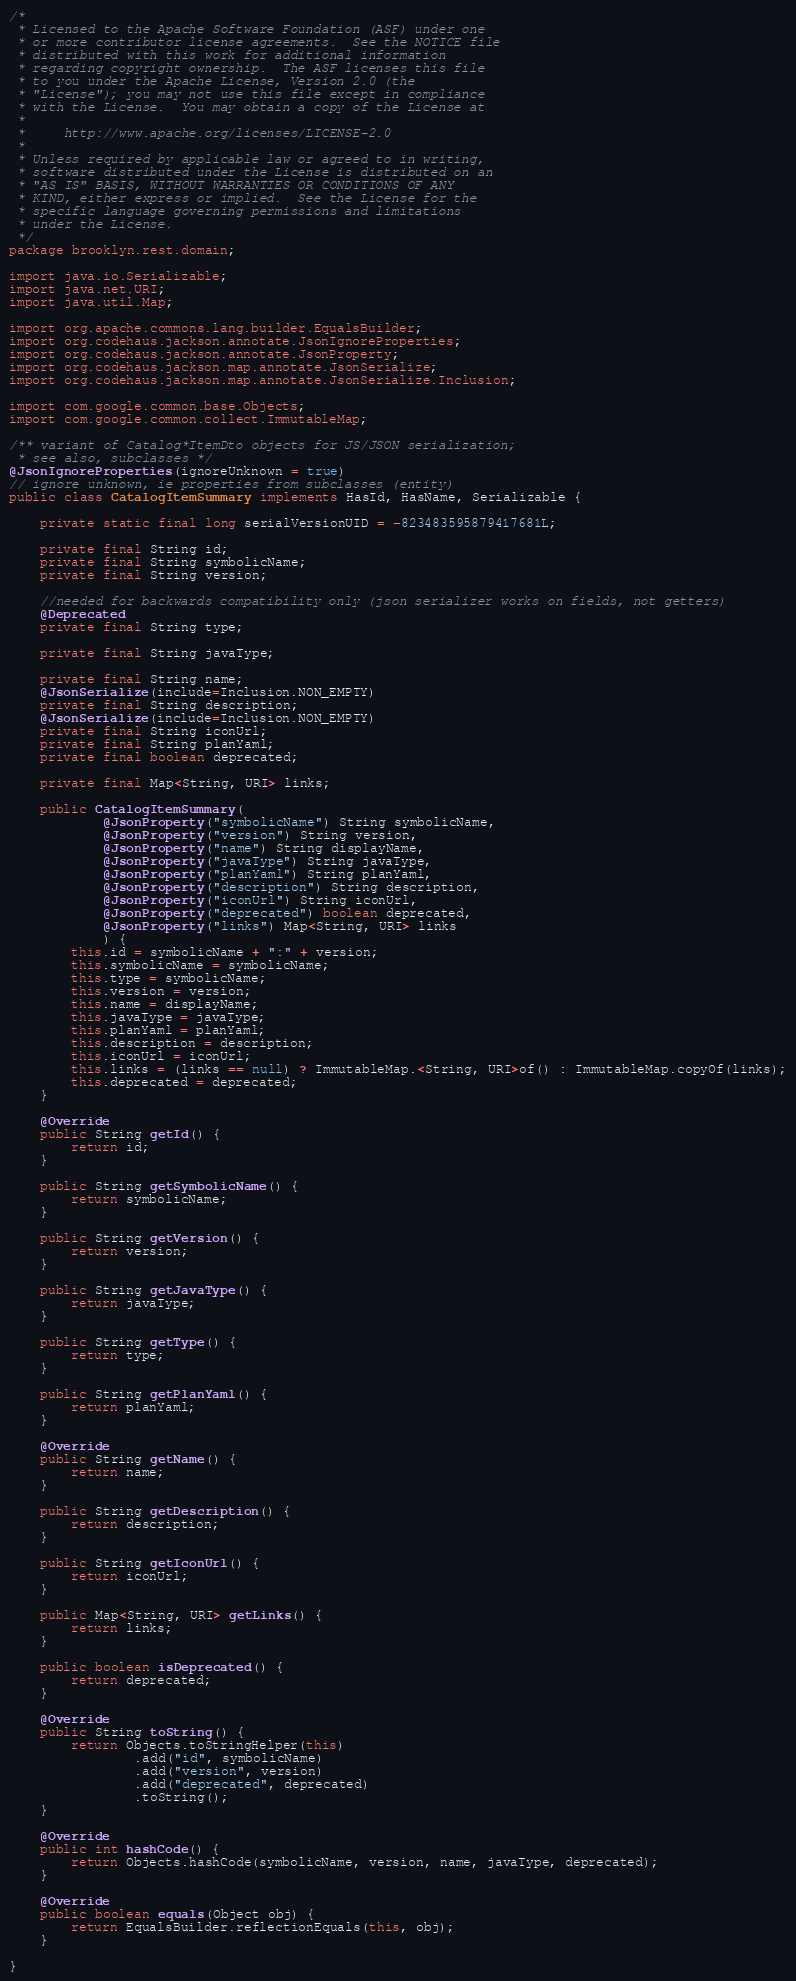<code> <loc_0><loc_0><loc_500><loc_500><_Java_>/*
 * Licensed to the Apache Software Foundation (ASF) under one
 * or more contributor license agreements.  See the NOTICE file
 * distributed with this work for additional information
 * regarding copyright ownership.  The ASF licenses this file
 * to you under the Apache License, Version 2.0 (the
 * "License"); you may not use this file except in compliance
 * with the License.  You may obtain a copy of the License at
 *
 *     http://www.apache.org/licenses/LICENSE-2.0
 *
 * Unless required by applicable law or agreed to in writing,
 * software distributed under the License is distributed on an
 * "AS IS" BASIS, WITHOUT WARRANTIES OR CONDITIONS OF ANY
 * KIND, either express or implied.  See the License for the
 * specific language governing permissions and limitations
 * under the License.
 */
package brooklyn.rest.domain;

import java.io.Serializable;
import java.net.URI;
import java.util.Map;

import org.apache.commons.lang.builder.EqualsBuilder;
import org.codehaus.jackson.annotate.JsonIgnoreProperties;
import org.codehaus.jackson.annotate.JsonProperty;
import org.codehaus.jackson.map.annotate.JsonSerialize;
import org.codehaus.jackson.map.annotate.JsonSerialize.Inclusion;

import com.google.common.base.Objects;
import com.google.common.collect.ImmutableMap;

/** variant of Catalog*ItemDto objects for JS/JSON serialization;
 * see also, subclasses */
@JsonIgnoreProperties(ignoreUnknown = true)
// ignore unknown, ie properties from subclasses (entity)
public class CatalogItemSummary implements HasId, HasName, Serializable {

    private static final long serialVersionUID = -823483595879417681L;
    
    private final String id;
    private final String symbolicName;
    private final String version;

    //needed for backwards compatibility only (json serializer works on fields, not getters)
    @Deprecated
    private final String type;
    
    private final String javaType;
    
    private final String name;
    @JsonSerialize(include=Inclusion.NON_EMPTY)
    private final String description;
    @JsonSerialize(include=Inclusion.NON_EMPTY)
    private final String iconUrl;
    private final String planYaml;
    private final boolean deprecated;
    
    private final Map<String, URI> links;

    public CatalogItemSummary(
            @JsonProperty("symbolicName") String symbolicName,
            @JsonProperty("version") String version,
            @JsonProperty("name") String displayName,
            @JsonProperty("javaType") String javaType,
            @JsonProperty("planYaml") String planYaml,
            @JsonProperty("description") String description,
            @JsonProperty("iconUrl") String iconUrl,
            @JsonProperty("deprecated") boolean deprecated,
            @JsonProperty("links") Map<String, URI> links
            ) {
        this.id = symbolicName + ":" + version;
        this.symbolicName = symbolicName;
        this.type = symbolicName;
        this.version = version;
        this.name = displayName;
        this.javaType = javaType;
        this.planYaml = planYaml;
        this.description = description;
        this.iconUrl = iconUrl;
        this.links = (links == null) ? ImmutableMap.<String, URI>of() : ImmutableMap.copyOf(links);
        this.deprecated = deprecated;
    }

    @Override
    public String getId() {
        return id;
    }

    public String getSymbolicName() {
        return symbolicName;
    }

    public String getVersion() {
        return version;
    }

    public String getJavaType() {
        return javaType;
    }

    public String getType() {
        return type;
    }

    public String getPlanYaml() {
        return planYaml;
    }

    @Override
    public String getName() {
        return name;
    }

    public String getDescription() {
        return description;
    }

    public String getIconUrl() {
        return iconUrl;
    }

    public Map<String, URI> getLinks() {
        return links;
    }

    public boolean isDeprecated() {
        return deprecated;
    }

    @Override
    public String toString() {
        return Objects.toStringHelper(this)
                .add("id", symbolicName)
                .add("version", version)
                .add("deprecated", deprecated)
                .toString();
    }

    @Override
    public int hashCode() {
        return Objects.hashCode(symbolicName, version, name, javaType, deprecated);
    }
    
    @Override
    public boolean equals(Object obj) {
        return EqualsBuilder.reflectionEquals(this, obj);
    }
    
}
</code> 